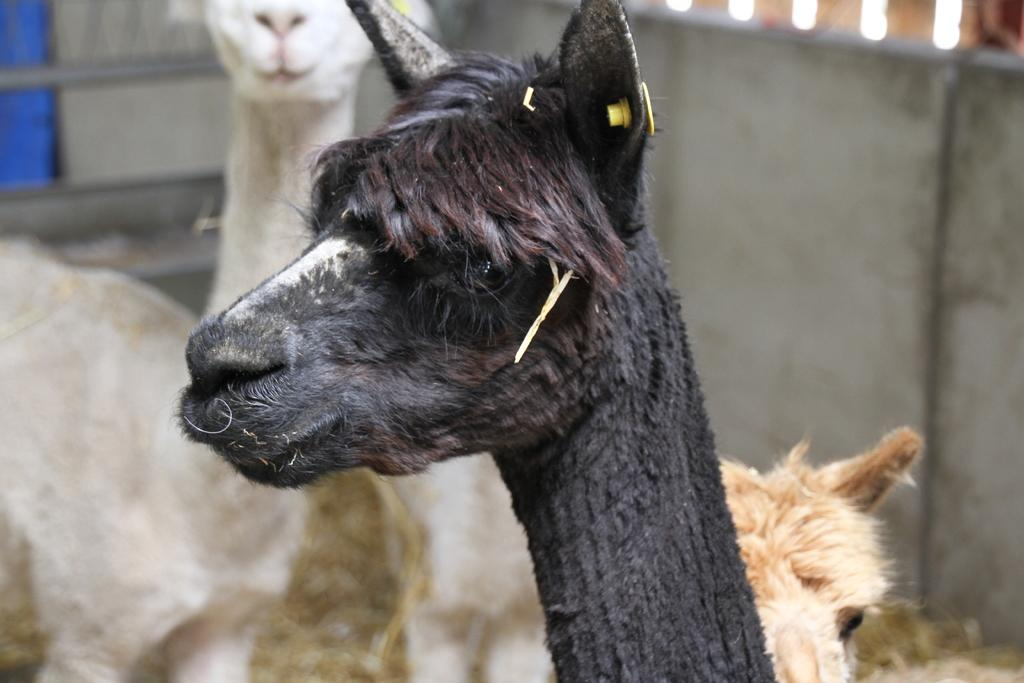What type of animal is in the image? There is an animal in the image, and it is black in color. Can you describe the other animals in the background of the image? The other animals in the background are white and brown in color. What else can be seen in the background of the image? There is a wall visible in the background of the image. What type of joke is being told by the animal in the image? There is no indication in the image that the animal is telling a joke, as it is a still image. 